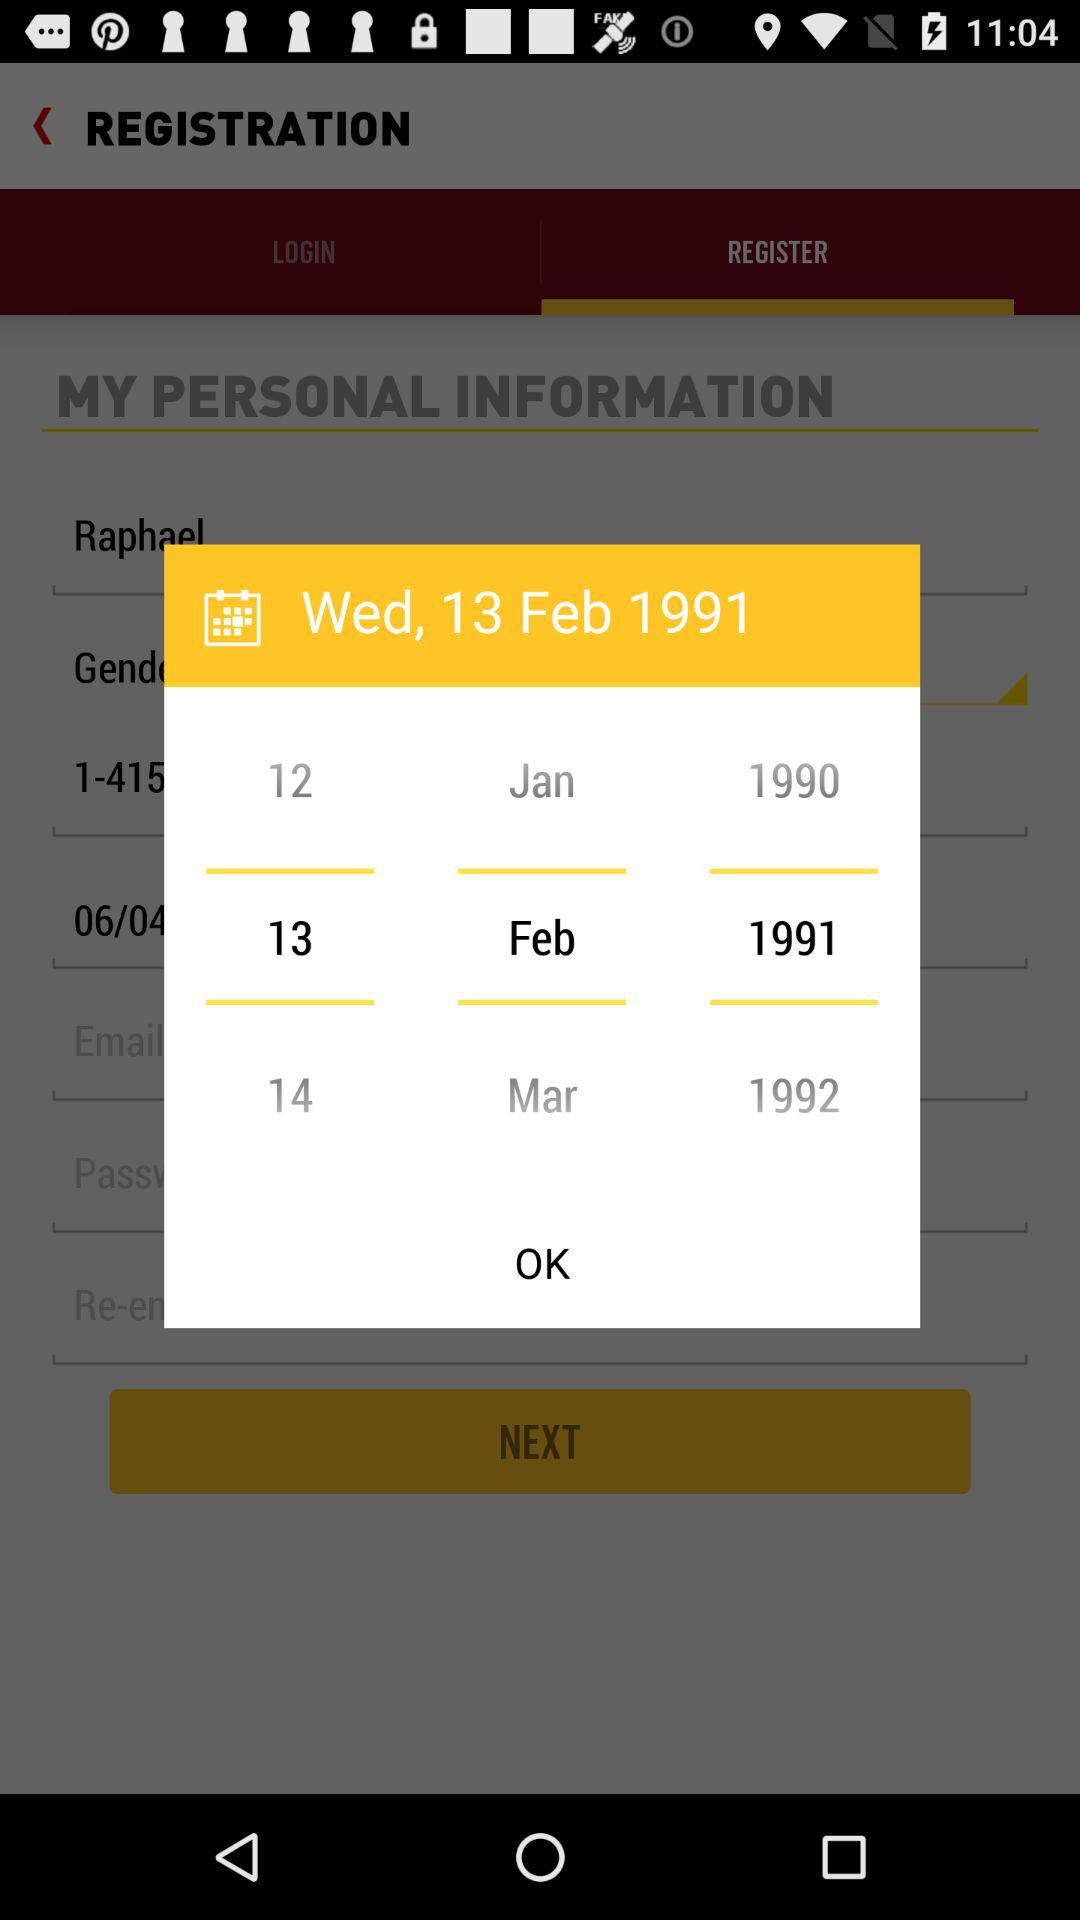How many years are shown on the calendar? 3 